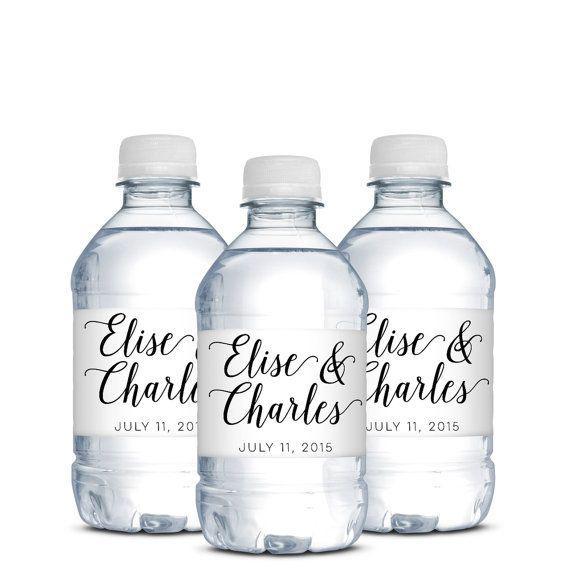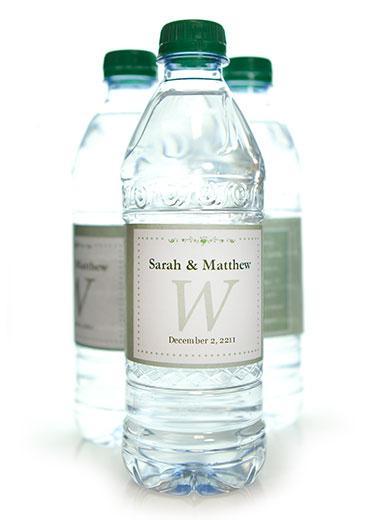The first image is the image on the left, the second image is the image on the right. For the images displayed, is the sentence "In one image, three bottles have white caps and identical labels, while the second image has one or more bottles with dark caps and different labeling." factually correct? Answer yes or no. Yes. The first image is the image on the left, the second image is the image on the right. For the images displayed, is the sentence "The bottle on the left has a blue and white striped label and there are at least three bottles on the right hand image." factually correct? Answer yes or no. No. 